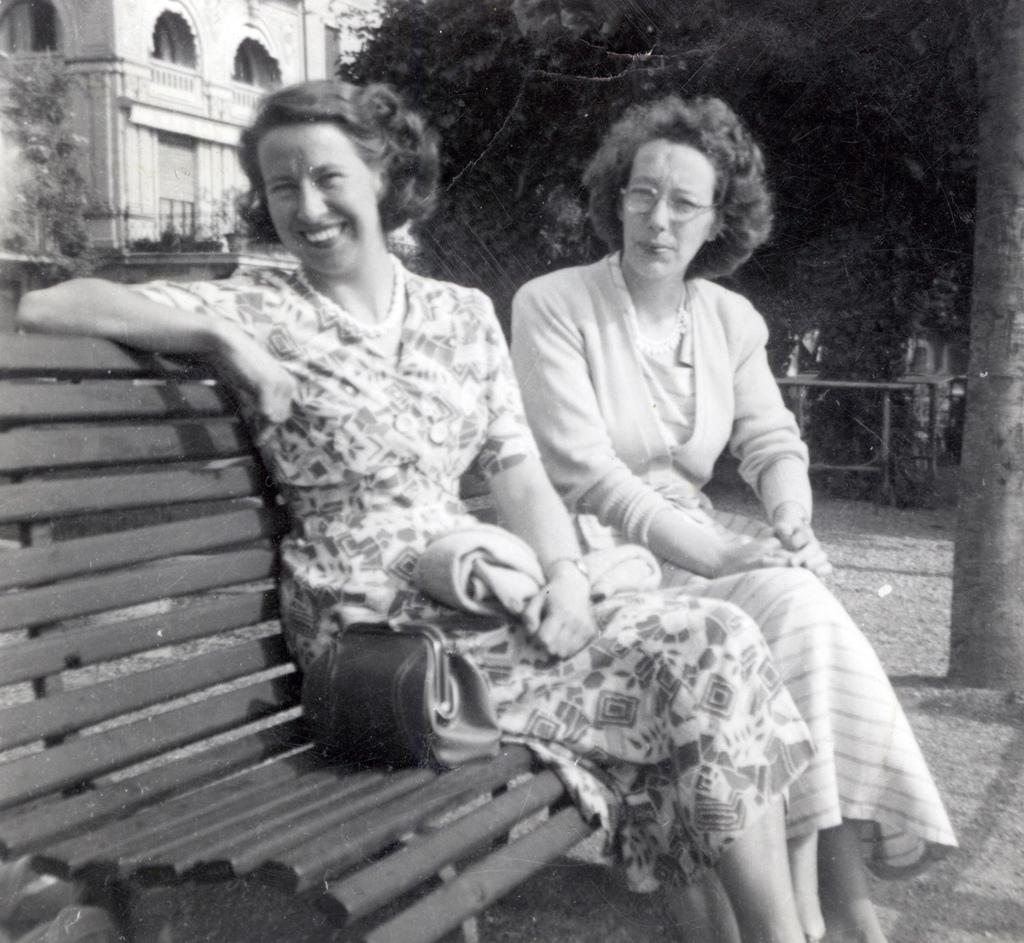What is the color scheme of the image? The image is black and white. What can be seen in the center of the image? There are women sitting on a bench in the center of the image. What is visible in the background of the image? There are trees and a building in the background of the image. How many copies of the building can be seen in the image? There is only one building visible in the image, so there are no copies of it. What level of respect is shown by the trees in the image? The trees in the image do not display any level of respect, as they are inanimate objects. 